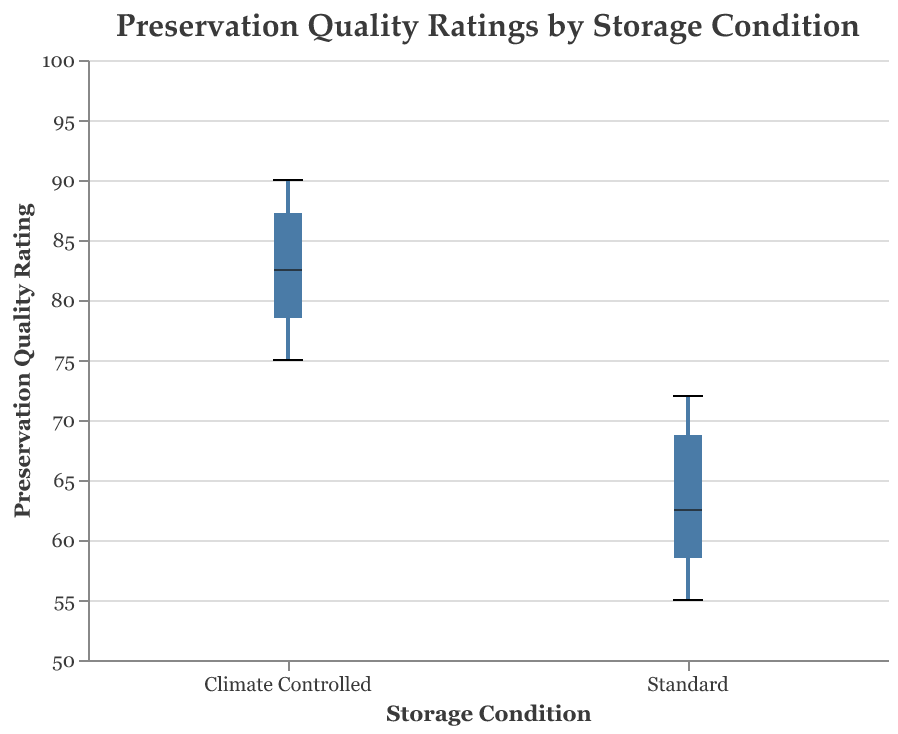What is the title of the figure? The title of the figure is displayed at the top of the chart. It reads "Preservation Quality Ratings by Storage Condition".
Answer: Preservation Quality Ratings by Storage Condition What does the x-axis represent? The x-axis represents the different storage conditions of the historical manuscripts. The two categories are "Climate Controlled" and "Standard".
Answer: Storage conditions What is the range of Preservation Quality Ratings displayed on the y-axis? The y-axis has a scale ranging from 50 to 100.
Answer: 50 to 100 Which storage condition has the higher median Preservation Quality Rating? The box plot visually indicates that the median line within the "Climate Controlled" category is higher compared to the "Standard" category.
Answer: Climate Controlled What is the minimum Preservation Quality Rating for the "Climate Controlled" storage condition? The minimum value for the "Climate Controlled" storage condition can be identified as the lowest whisker of the "Climate Controlled" box plot. It is 75.
Answer: 75 What is the approximate average Preservation Quality Rating for "Standard" storage condition if the values are equally spaced? To approximate the average, we consider the midpoint of the range. The boxplot's range is from approximately 55 to 72. So, (55+72)/2 = 63.5.
Answer: 63.5 How much higher is the highest Preservation Quality Rating in the "Climate Controlled" condition compared to the highest score in the "Standard" condition? The highest rating in "Climate Controlled" is 90, while in "Standard" it is 72. The difference is 90 - 72.
Answer: 18 Which document under the "Climate Controlled" condition has the highest Preservation Quality Rating? According to the data provided, under "Climate Controlled" condition, "Constitution of the United States" has the highest rating of 90.
Answer: Constitution of the United States What's the range of Preservation Quality Ratings for the "Standard" storage condition? The range is calculated as the difference between the maximum and minimum ratings within the "Standard" condition. The max is 72 and the min is 55. So, 72 - 55 = 17.
Answer: 17 